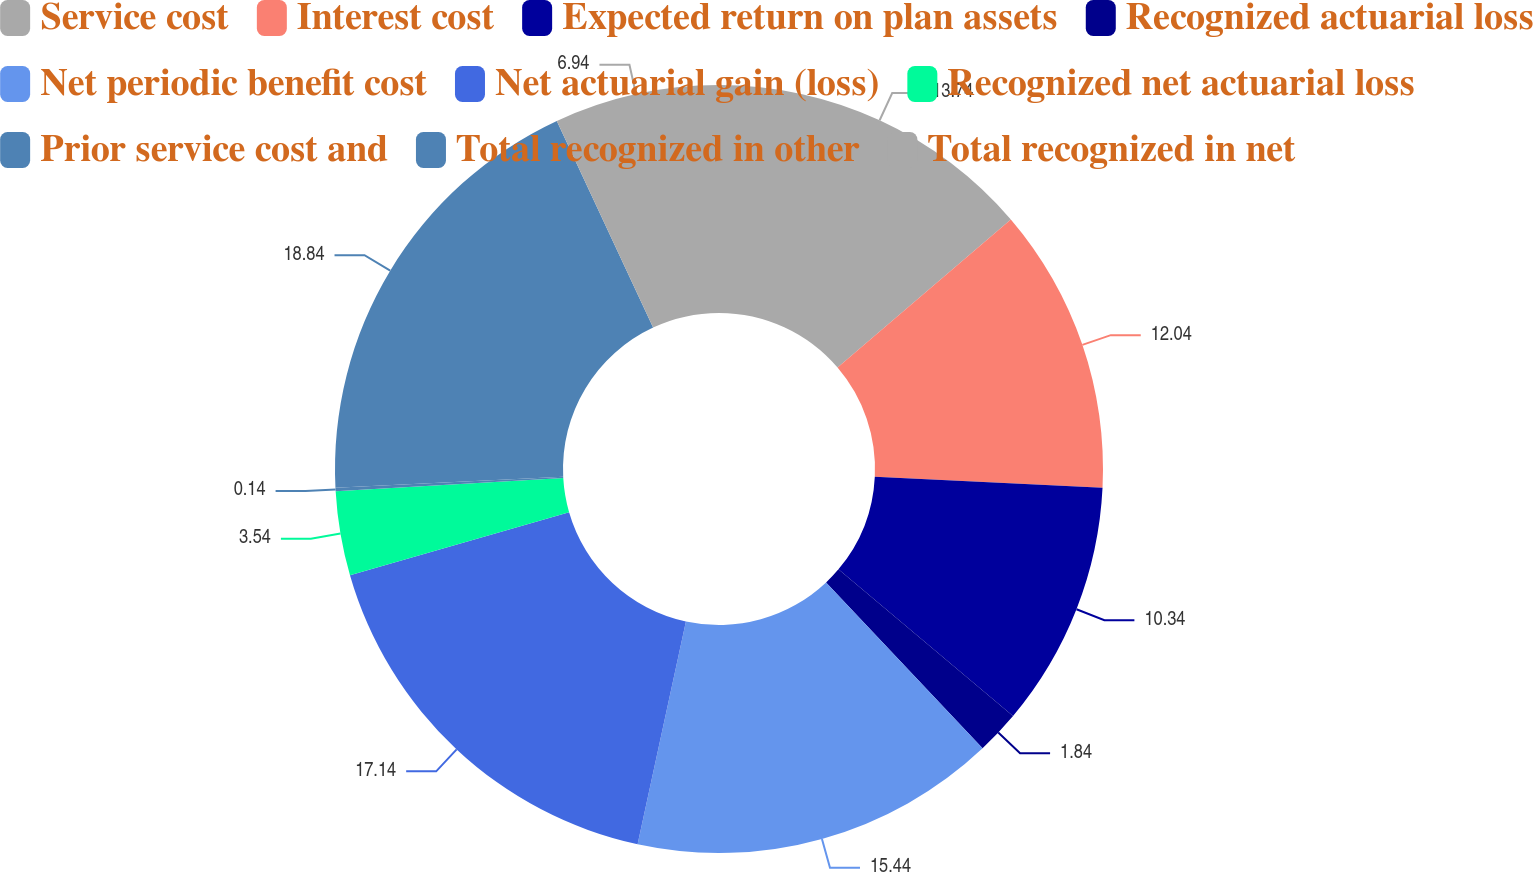Convert chart to OTSL. <chart><loc_0><loc_0><loc_500><loc_500><pie_chart><fcel>Service cost<fcel>Interest cost<fcel>Expected return on plan assets<fcel>Recognized actuarial loss<fcel>Net periodic benefit cost<fcel>Net actuarial gain (loss)<fcel>Recognized net actuarial loss<fcel>Prior service cost and<fcel>Total recognized in other<fcel>Total recognized in net<nl><fcel>13.74%<fcel>12.04%<fcel>10.34%<fcel>1.84%<fcel>15.44%<fcel>17.14%<fcel>3.54%<fcel>0.14%<fcel>18.84%<fcel>6.94%<nl></chart> 